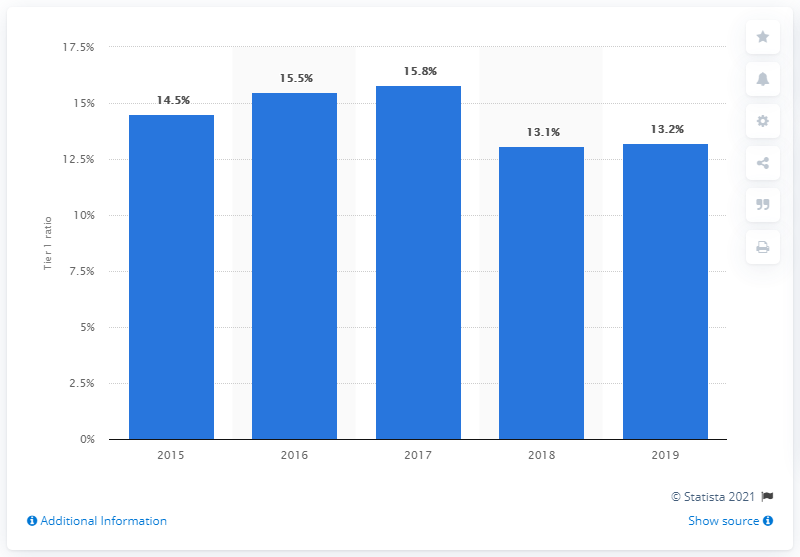Identify some key points in this picture. The tier 1 ratio of Credit Agricole in 2019 was 13.2%. 